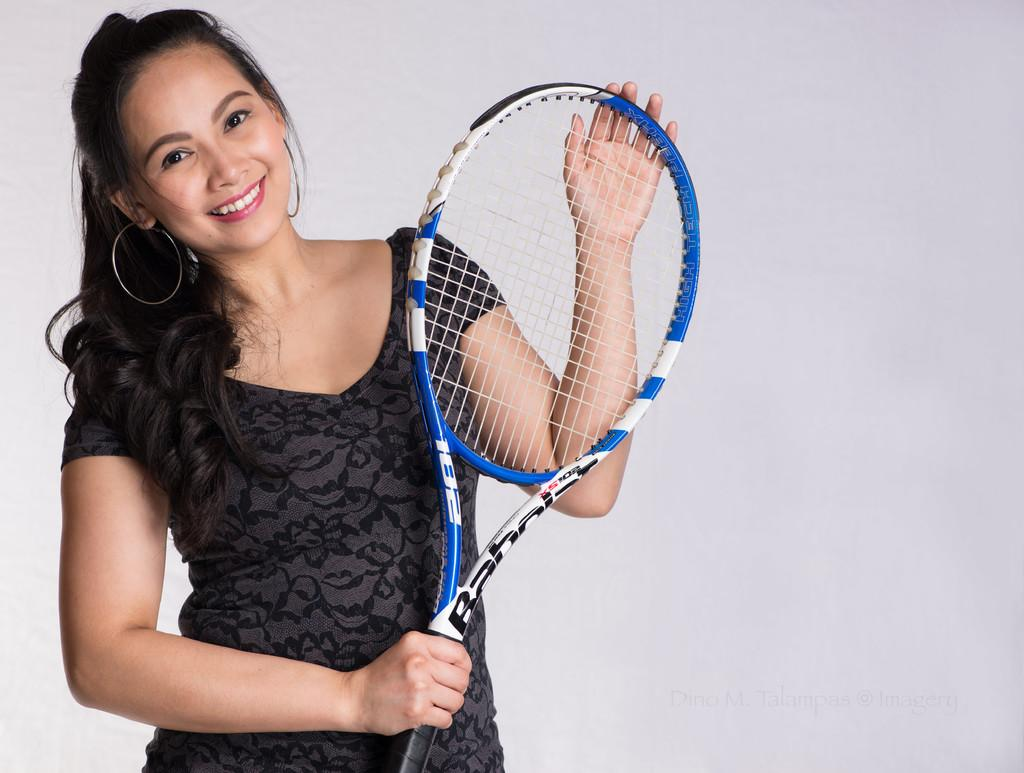What is the main subject of the image? The main subject of the image is a woman. What is the woman holding in her hand? The woman is holding a shuttle bat in her hand. What is the woman wearing? The woman is wearing a black dress. What type of gun can be seen in the woman's hand in the image? There is no gun present in the image; the woman is holding a shuttle bat. What type of dog is sitting next to the woman in the image? There is no dog present in the image; the woman is the only subject visible. 